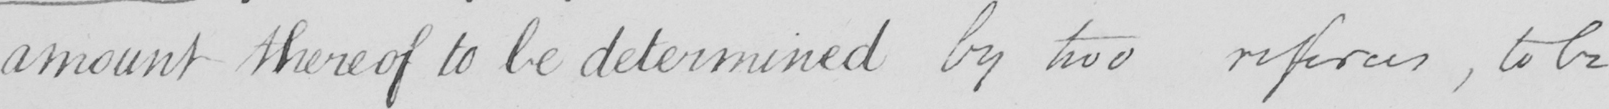Can you read and transcribe this handwriting? amount thereof to be determined by two referees , to be 